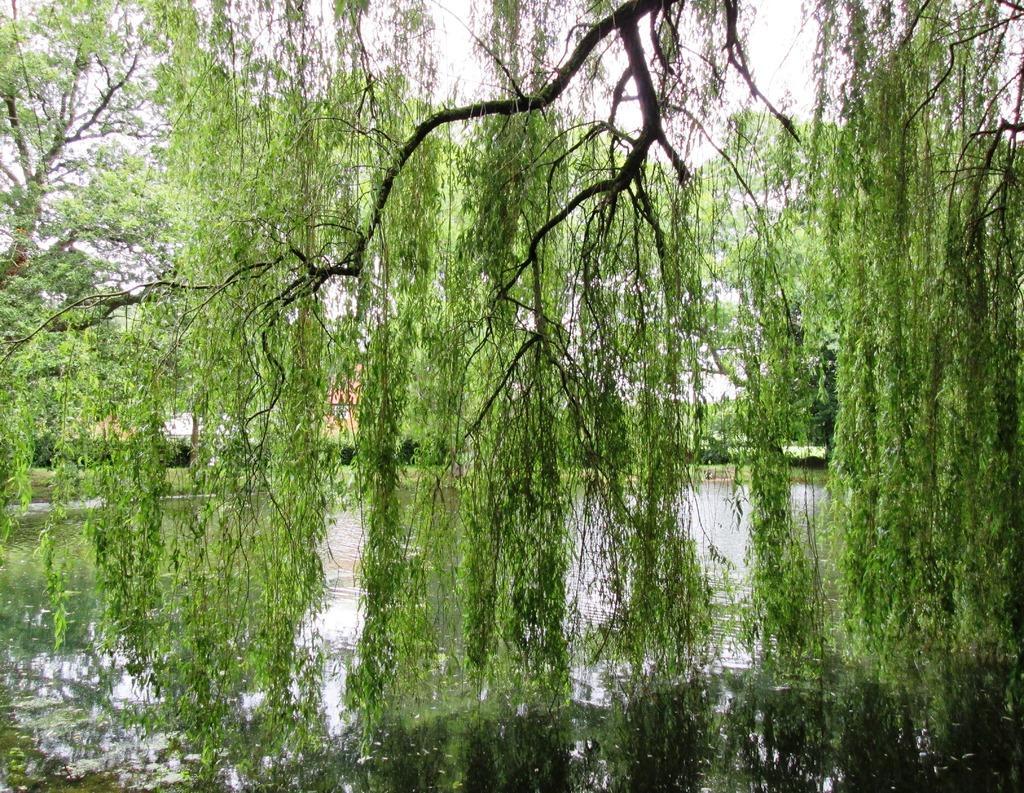Describe this image in one or two sentences. These are the trees, in the down side it is water. 